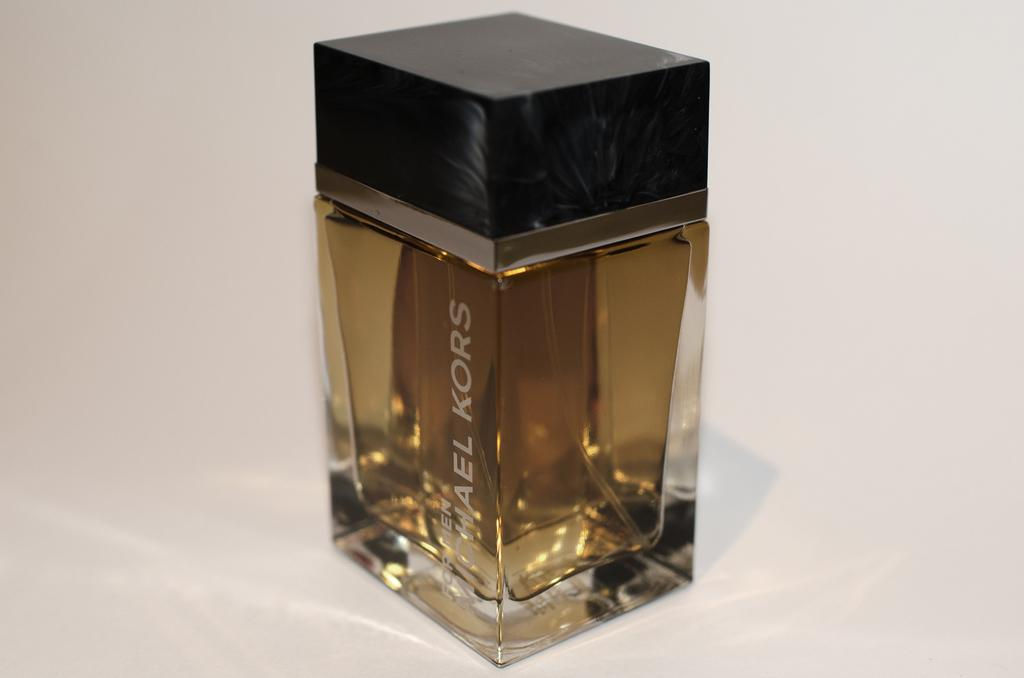<image>
Render a clear and concise summary of the photo. A bottle of Michael Kors perfume that is brown. 